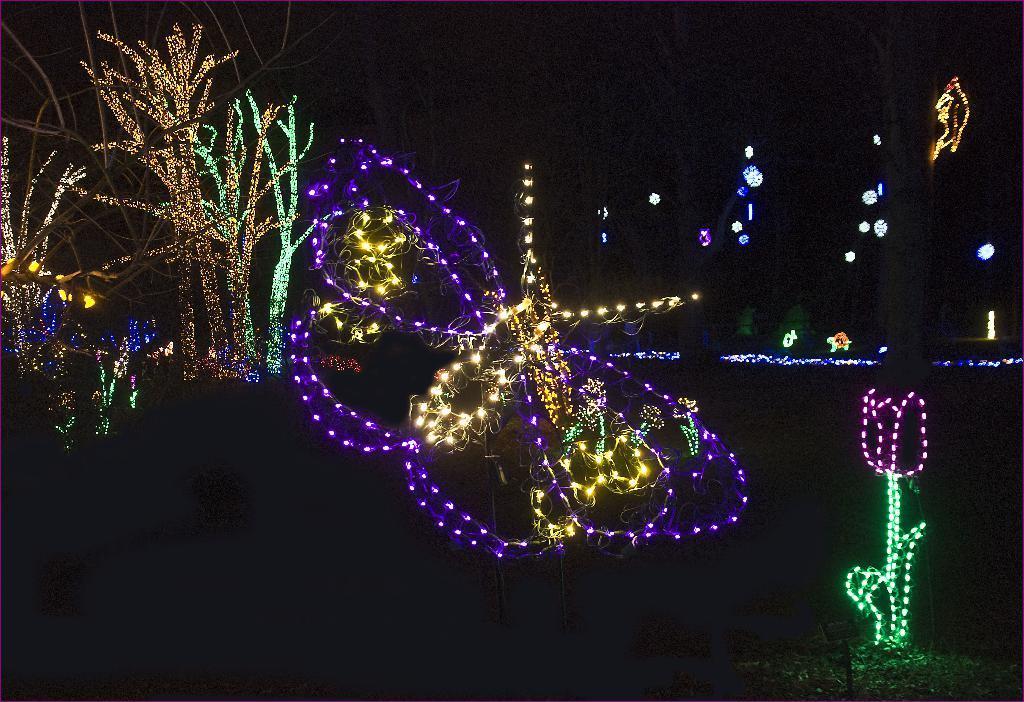Describe this image in one or two sentences. In this image is during night and I can see there is a lighting on trees and background is very dark 